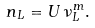Convert formula to latex. <formula><loc_0><loc_0><loc_500><loc_500>n _ { L } = U \, \nu ^ { m } _ { L } .</formula> 